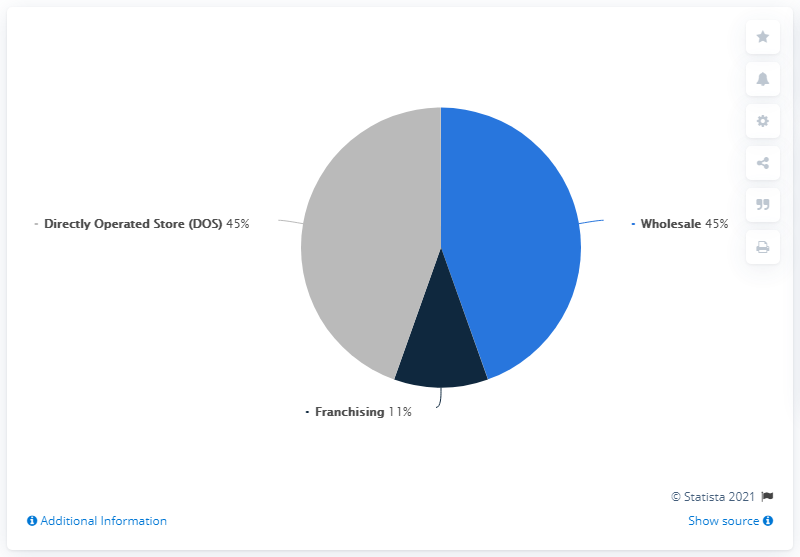Outline some significant characteristics in this image. Geox's wholesale revenues accounted for 45% of the company's total revenues in Italy. Yes, the value of directly operated stores is the same as wholesale. The color of wholesale in the pie segment is blue. 